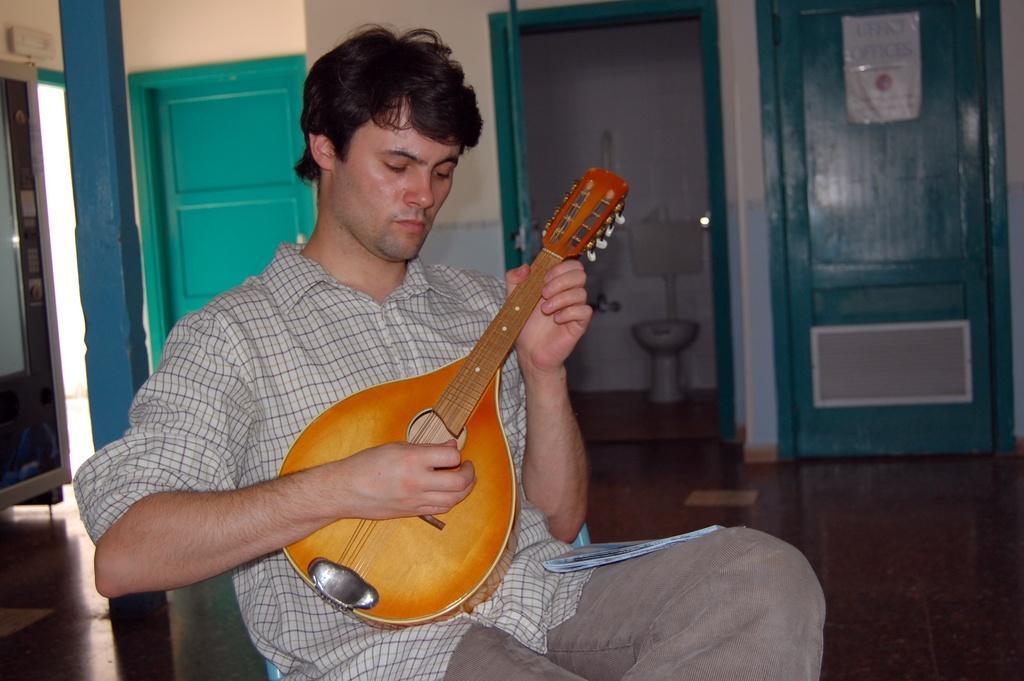Please provide a concise description of this image. In this image in the middle, he wear check shirt and trouser, he is playing musical instrument. In the background there is door, pillar, bathroom and wall. 